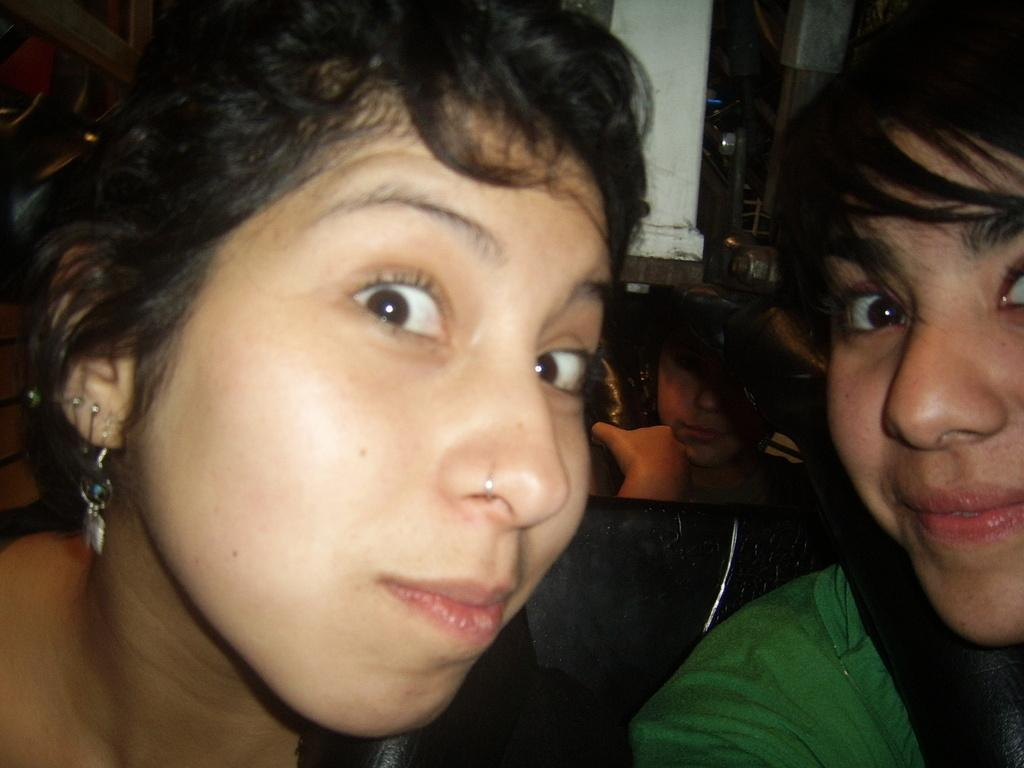How many people are in the image? There are people in the image, but the exact number is not specified. What is visible in the background of the image? There is a wall and some objects visible in the background of the image. How many spiders are crawling on the wall in the image? There is no mention of spiders in the image, so we cannot determine their presence or quantity. What type of angle is depicted in the image? The image does not depict an angle, as it features people and a wall in the background. 